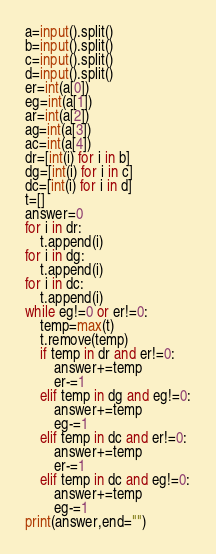<code> <loc_0><loc_0><loc_500><loc_500><_Python_>a=input().split()
b=input().split()
c=input().split()
d=input().split()
er=int(a[0])
eg=int(a[1])
ar=int(a[2])
ag=int(a[3])
ac=int(a[4])
dr=[int(i) for i in b]
dg=[int(i) for i in c]
dc=[int(i) for i in d]
t=[]
answer=0
for i in dr:
	t.append(i)
for i in dg:
	t.append(i)
for i in dc:
	t.append(i)
while eg!=0 or er!=0:
	temp=max(t)
	t.remove(temp)
	if temp in dr and er!=0:
		answer+=temp
		er-=1
	elif temp in dg and eg!=0:
		answer+=temp
		eg-=1
	elif temp in dc and er!=0:
		answer+=temp
		er-=1
	elif temp in dc and eg!=0:
		answer+=temp
		eg-=1
print(answer,end="")</code> 